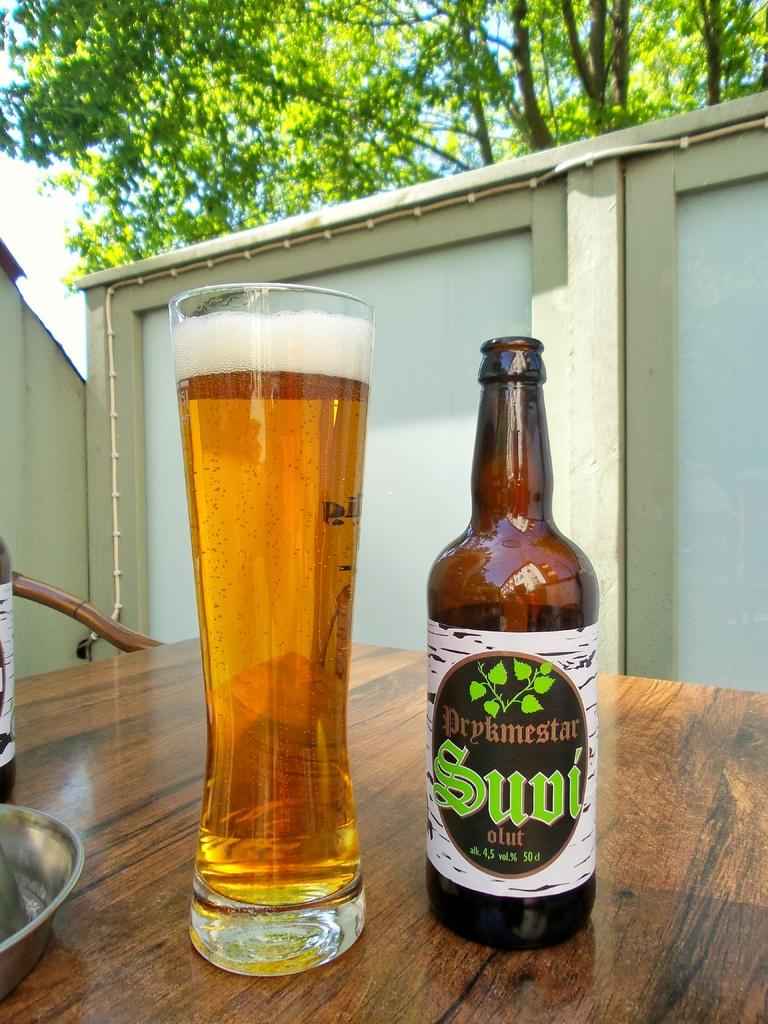What is on the table in the image? There is a glass and a bottle on the table in the image. What can be seen in the background of the image? There is a building and a tree in the background of the image. How many oranges are hanging from the tree in the image? There are no oranges present in the image; the tree is not described as having any fruit. 